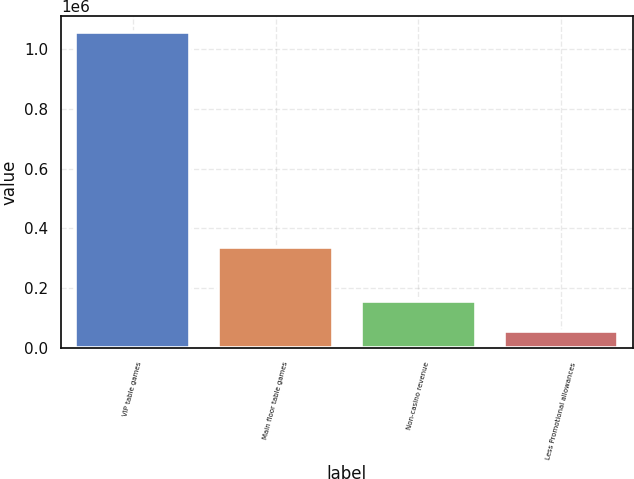Convert chart to OTSL. <chart><loc_0><loc_0><loc_500><loc_500><bar_chart><fcel>VIP table games<fcel>Main floor table games<fcel>Non-casino revenue<fcel>Less Promotional allowances<nl><fcel>1.05533e+06<fcel>338698<fcel>156035<fcel>56114<nl></chart> 